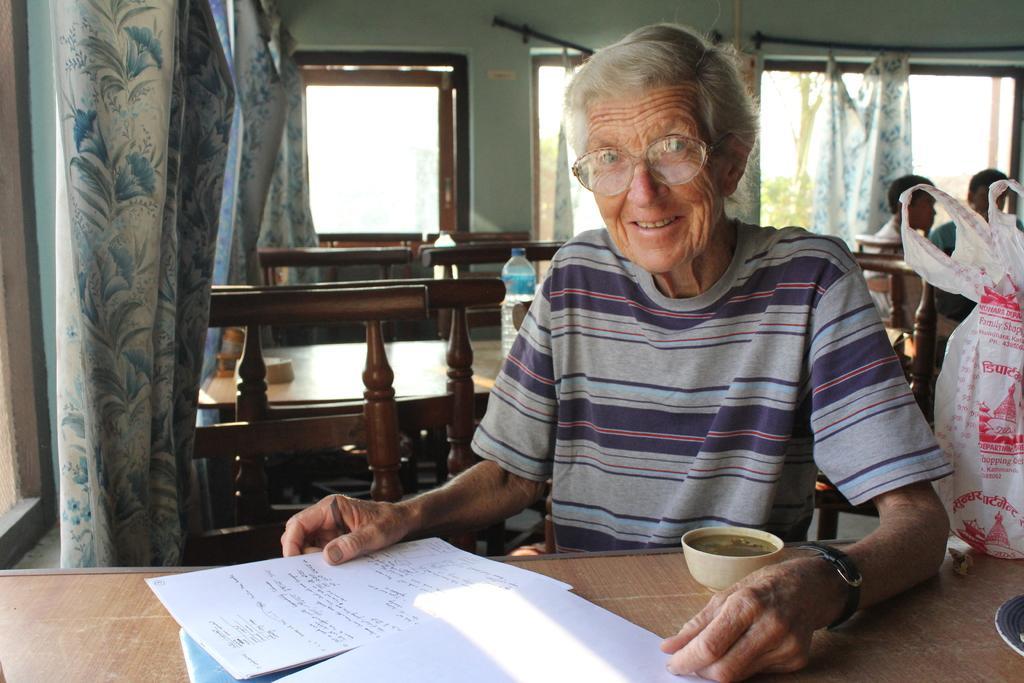Please provide a concise description of this image. In this picture I can see a human sitting in the chair and I can see a bowl and few papers and a carry bag and looks like a plate on the table and I can see few chairs and tables in the back and couple of water bottles on the tables and I can see couple of them are sitting in the chairs on the top right corner of the picture and I can see curtains to the windows. 